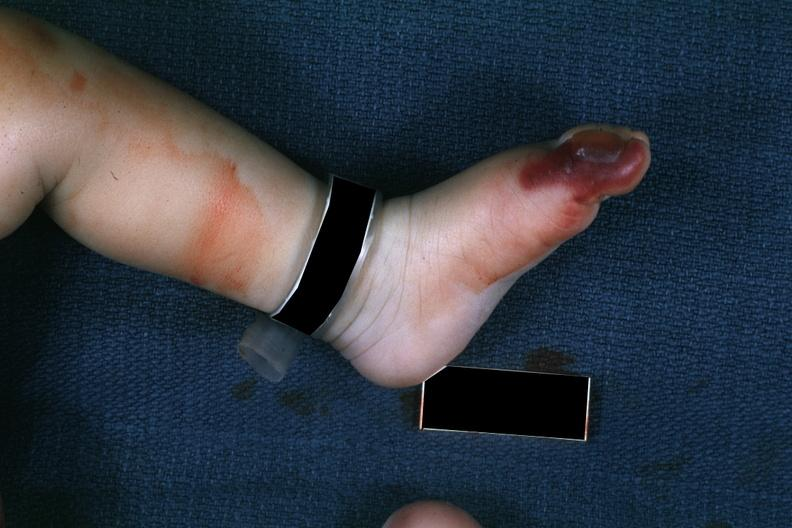s photo present?
Answer the question using a single word or phrase. No 